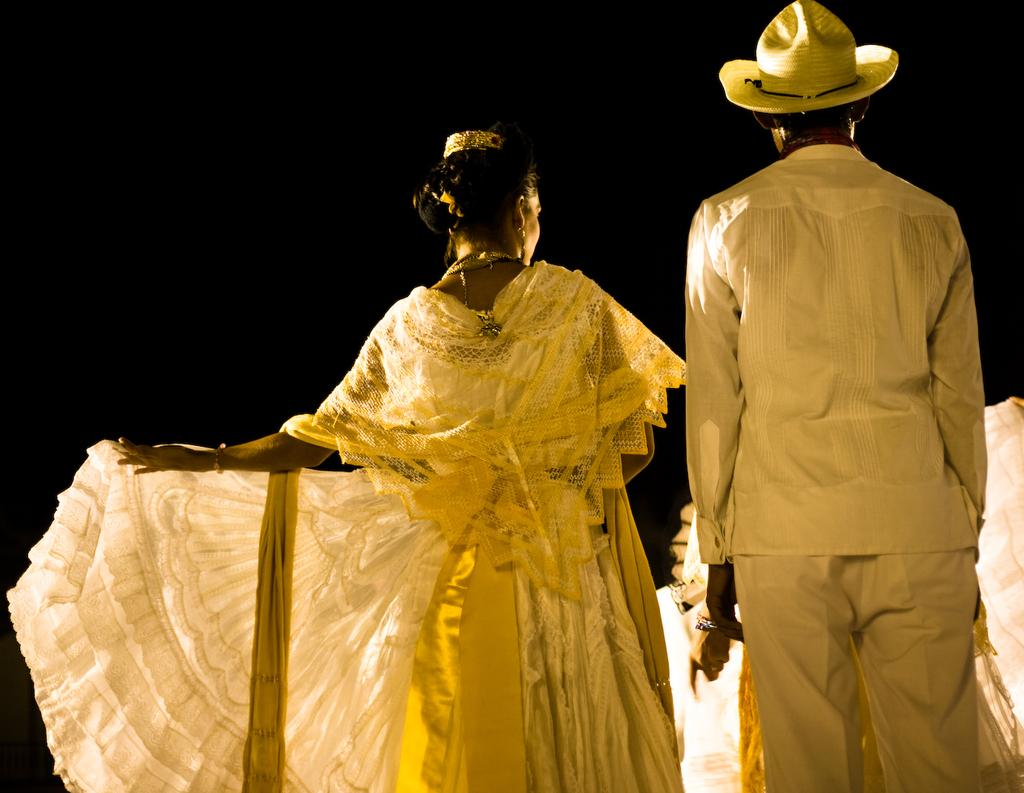What is the gender of the person in the image? There is a man in the image. What is the man doing in the image? The man is standing. What is the man wearing in the image? The man is wearing a hat. Is there anyone else in the image besides the man? Yes, there is a woman in the image. What is the woman doing in the image? The woman is standing. What type of stream can be seen flowing through the town in the image? There is no stream or town present in the image; it features a man and a woman standing. 